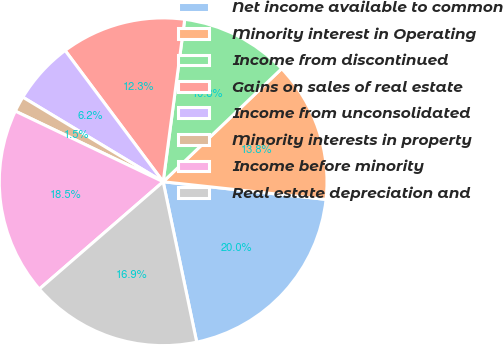Convert chart to OTSL. <chart><loc_0><loc_0><loc_500><loc_500><pie_chart><fcel>Net income available to common<fcel>Minority interest in Operating<fcel>Income from discontinued<fcel>Gains on sales of real estate<fcel>Income from unconsolidated<fcel>Minority interests in property<fcel>Income before minority<fcel>Real estate depreciation and<nl><fcel>20.0%<fcel>13.85%<fcel>10.77%<fcel>12.31%<fcel>6.16%<fcel>1.54%<fcel>18.46%<fcel>16.92%<nl></chart> 